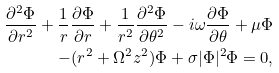Convert formula to latex. <formula><loc_0><loc_0><loc_500><loc_500>\frac { \partial ^ { 2 } \Phi } { \partial r ^ { 2 } } + \frac { 1 } { r } \frac { \partial \Phi } { \partial r } + \frac { 1 } { r ^ { 2 } } \frac { \partial ^ { 2 } \Phi } { \partial \theta ^ { 2 } } - i \omega \frac { \partial \Phi } { \partial \theta } + \mu \Phi \\ - ( r ^ { 2 } + \Omega ^ { 2 } z ^ { 2 } ) \Phi + \sigma | \Phi | ^ { 2 } \Phi = 0 ,</formula> 